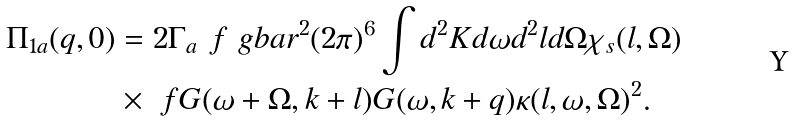<formula> <loc_0><loc_0><loc_500><loc_500>\Pi _ { 1 a } ( q , 0 ) & = 2 \Gamma _ { a } \ f { \ g b a r ^ { 2 } } { ( 2 \pi ) ^ { 6 } } \int d ^ { 2 } K d \omega d ^ { 2 } l d \Omega \chi _ { s } ( l , \Omega ) \\ & \times \ f { G ( \omega + \Omega , k + l ) G ( \omega , k + q ) } { \kappa ( l , \omega , \Omega ) ^ { 2 } } .</formula> 